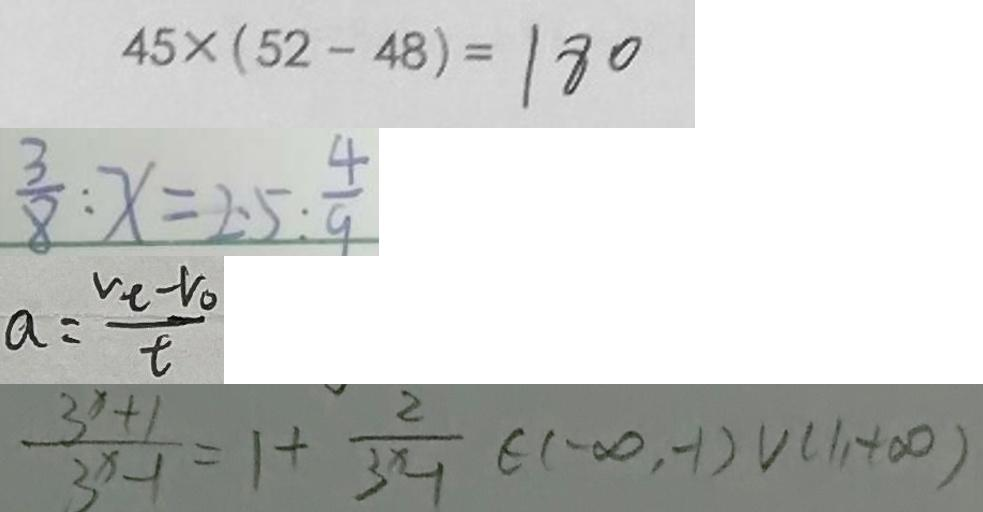<formula> <loc_0><loc_0><loc_500><loc_500>4 5 \times ( 5 2 - 4 8 ) = 1 8 0 
 \frac { 3 } { 8 } : x = 2 . 5 : \frac { 4 } { 9 } 
 a = \frac { v _ { t } - v _ { 0 } } { t } 
 \frac { 3 ^ { x } + 1 } { 3 ^ { x } - 1 } = 1 + \frac { 2 } { 3 ^ { x } - 1 } \in ( - \infty , - 1 ) \cup ( 1 , + \infty )</formula> 